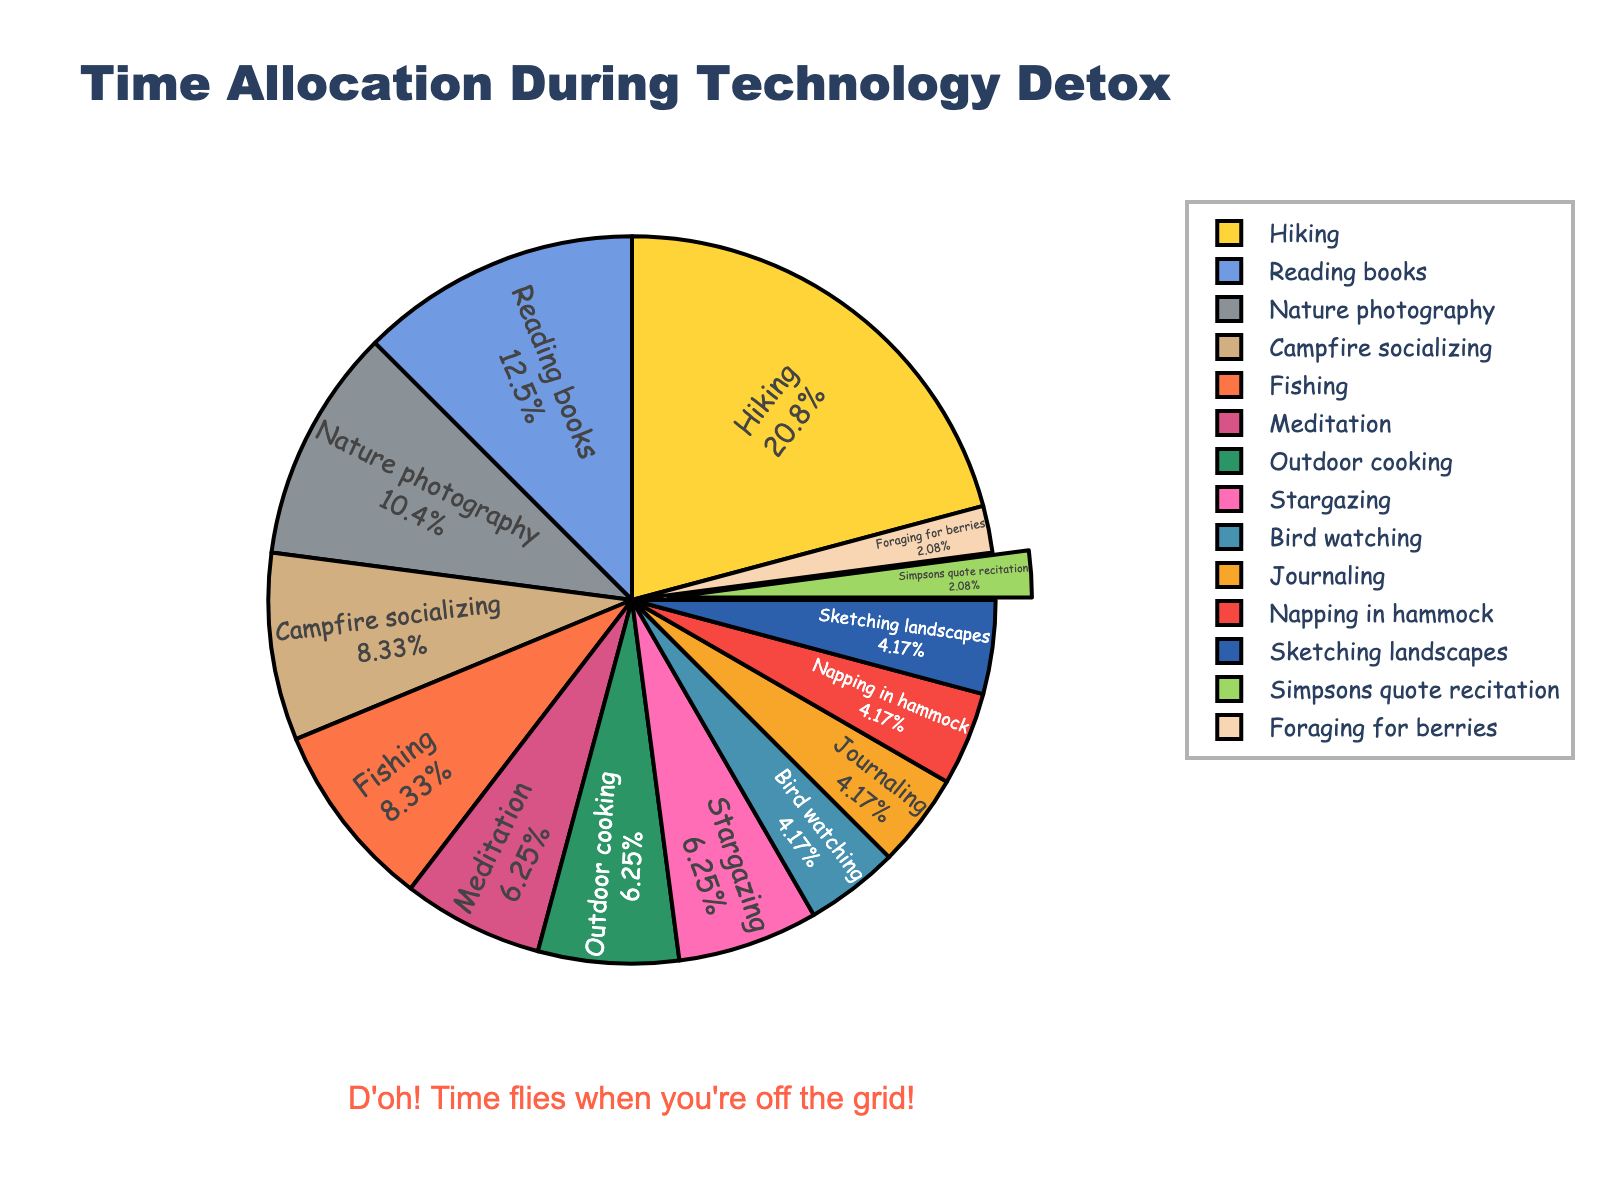Which activity takes up the most time during the technology detox? In the pie chart, the activity with the largest slice represents the one that takes up the most time.
Answer: Hiking How many total hours are spent on activities involving social interaction? The activities involving social interaction are "Campfire socializing" (2 hours) and "Simpsons quote recitation" (0.5 hours). Summing these up: 2 + 0.5 = 2.5 hours.
Answer: 2.5 hours What proportion of time is spent on relaxation activities (napping, meditation, journaling)? The relaxation activities are "Napping in hammock" (1 hour), "Meditation" (1.5 hours), and "Journaling" (1 hour). Summing these up: 1 + 1.5 + 1 = 3.5 hours. The total time spent on all activities is 22 hours. Therefore, the proportion is 3.5 / 22 \* 100 ≈ 15.9%.
Answer: 15.9% Which activities have an equal amount of time allocated to them? From the pie chart, "Meditation," "Outdoor cooking," and "Stargazing" each have 1.5 hours allocated to them. "Journaling," "Napping in hammock," and "Bird watching" each have 1 hour allocated to them.
Answer: Meditation, Outdoor cooking, Stargazing; Journaling, Napping in hammock, Bird watching By what factor is the time spent on hiking greater than the time spent on fishing? The time spent on hiking is 5 hours and on fishing is 2 hours. The factor is calculated as 5 / 2 = 2.5.
Answer: 2.5 How much more time is allocated to nature photography compared to sketching landscapes? Nature photography has 2.5 hours and sketching landscapes has 1 hour. The difference is 2.5 - 1 = 1.5 hours.
Answer: 1.5 hours Does foraging for berries take up more or less than half the time spent on nature photography? Foraging for berries takes 0.5 hours, and nature photography takes 2.5 hours. Half of 2.5 hours is 1.25 hours. Since 0.5 is less than 1.25, foraging for berries takes up less time.
Answer: Less What is the percentage of time spent on "Simpsons quote recitation" compared to the total detox time? "Simpsons quote recitation" takes up 0.5 hours. The total time for all activities is 22 hours. The percentage is (0.5 / 22) * 100 ≈ 2.3%.
Answer: 2.3% Calculate the sum of hours spent on activities that involve physical movement (hiking, fishing, foraging for berries). Physical movement activities are "Hiking" (5 hours), "Fishing" (2 hours), and "Foraging for berries" (0.5 hours). Summing these up: 5 + 2 + 0.5 = 7.5 hours.
Answer: 7.5 hours 